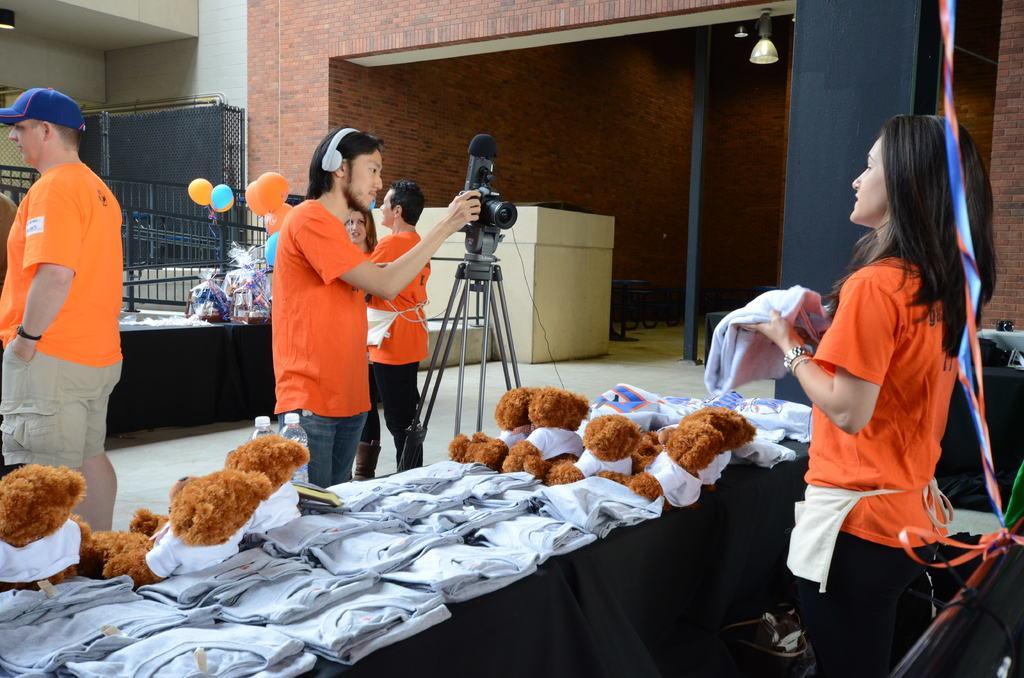Please provide a concise description of this image. In this image I can see few people standing. There is a person holding a cloth. There are toys and clothes on a table. Also there is another table with some objects on it. There are balloons, lights, walls and there are some other objects. Also there is a camera with tripod stand. 